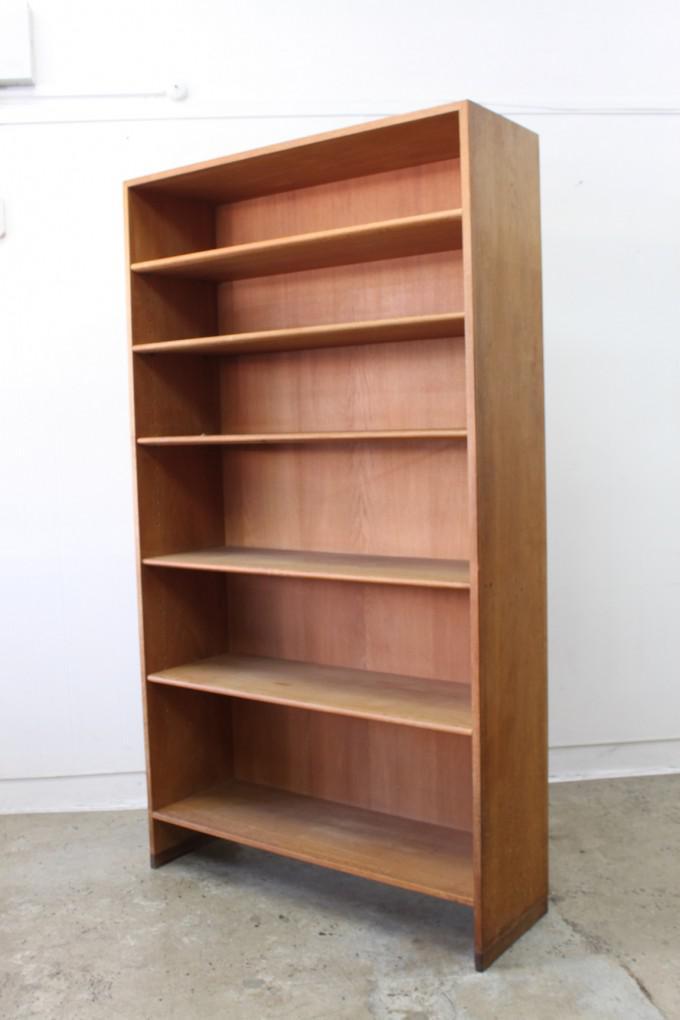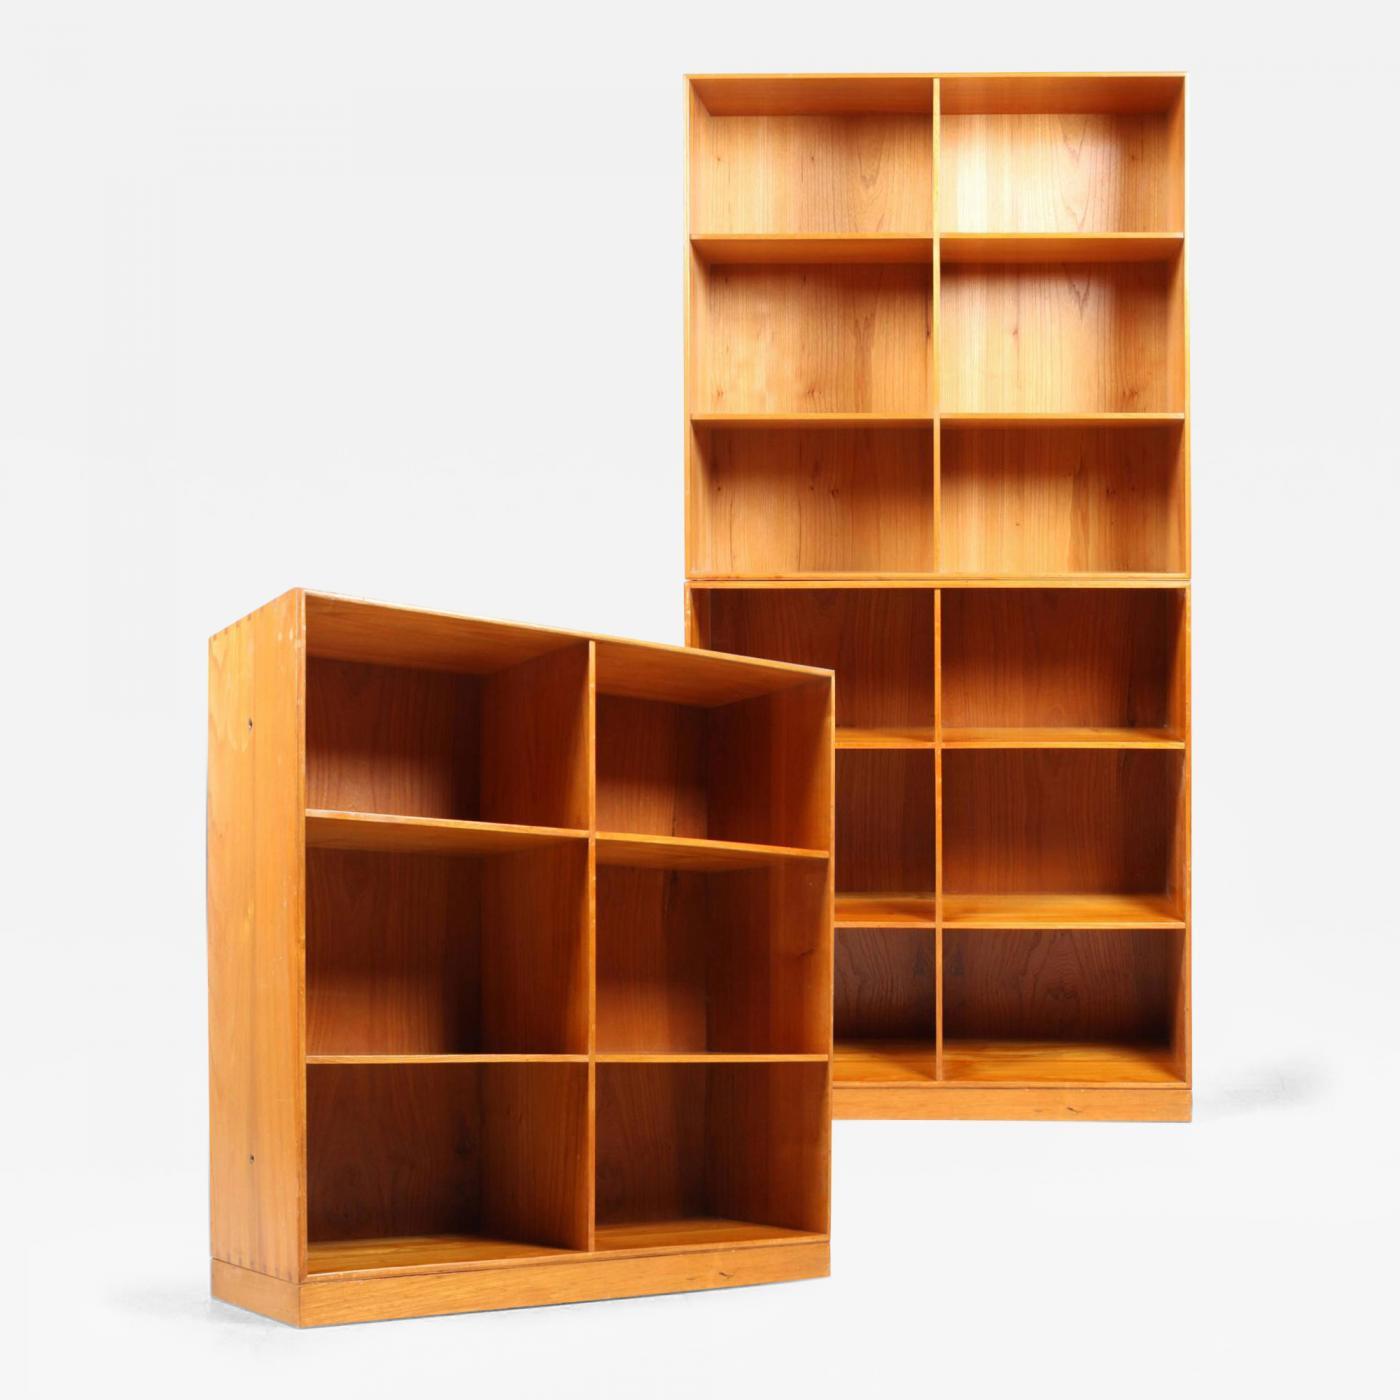The first image is the image on the left, the second image is the image on the right. Evaluate the accuracy of this statement regarding the images: "One image contains a tall, brown bookshelf; and the other contains a bookshelf with cupboards at the bottom.". Is it true? Answer yes or no. No. 